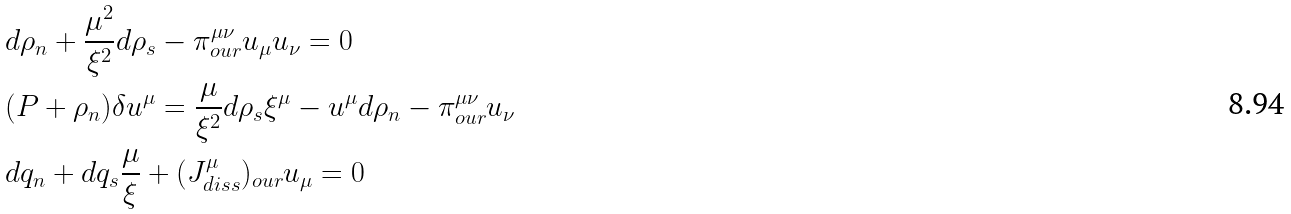<formula> <loc_0><loc_0><loc_500><loc_500>& d \rho _ { n } + \frac { \mu ^ { 2 } } { \xi ^ { 2 } } d \rho _ { s } - \pi _ { o u r } ^ { \mu \nu } u _ { \mu } u _ { \nu } = 0 \\ & ( P + \rho _ { n } ) \delta u ^ { \mu } = \frac { \mu } { \xi ^ { 2 } } d \rho _ { s } \xi ^ { \mu } - u ^ { \mu } d \rho _ { n } - \pi _ { o u r } ^ { \mu \nu } u _ { \nu } \\ & d q _ { n } + d q _ { s } \frac { \mu } { \xi } + ( J ^ { \mu } _ { d i s s } ) _ { o u r } u _ { \mu } = 0 \\</formula> 